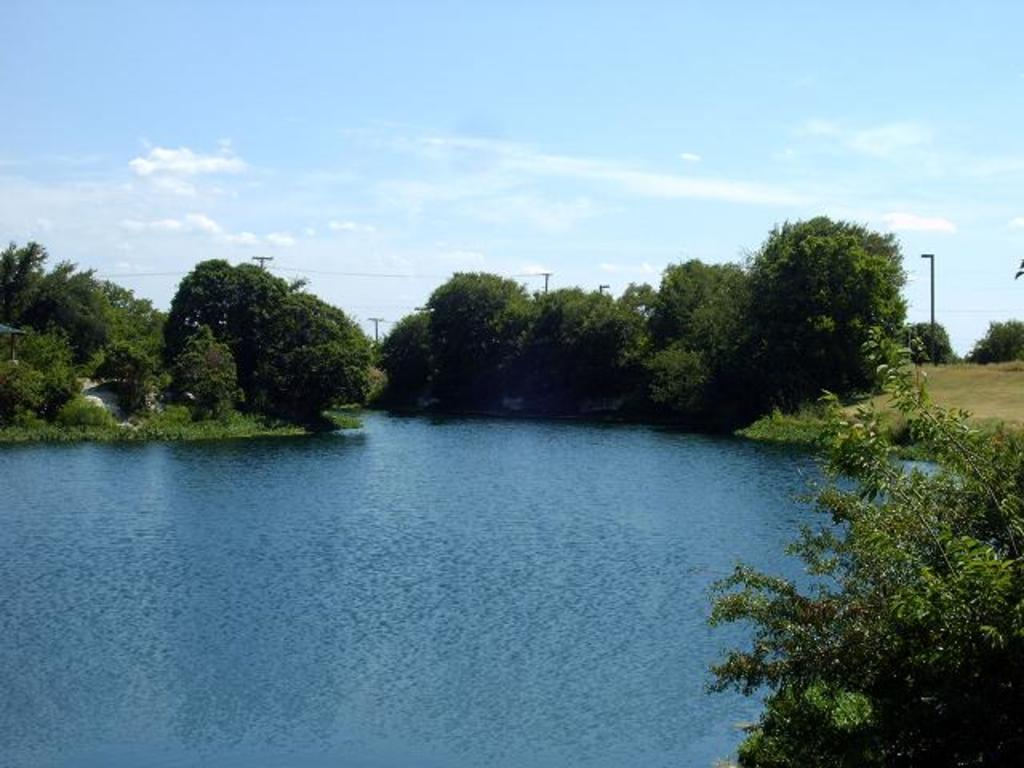What body of water is visible in the image? There is a lake in the image. What type of vegetation can be seen in the background of the image? There are trees, plants, and grass in the background of the image. What man-made structures are present in the background of the image? There are electric poles and wires in the background of the image. What is visible at the top of the image? The sky is visible at the top of the image. What can be seen in the sky? Clouds are present in the sky. What type of government is depicted in the image? There is no depiction of a government in the image; it features a lake, vegetation, man-made structures, and the sky. How many points can be seen in the image? There are no points visible in the image. 